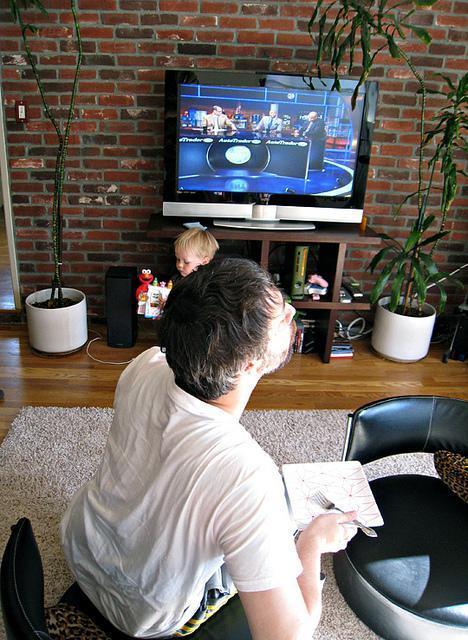How many chairs are there?
Give a very brief answer. 2. How many potted plants are in the picture?
Give a very brief answer. 2. How many tvs are visible?
Give a very brief answer. 1. How many people can be seen?
Give a very brief answer. 1. 